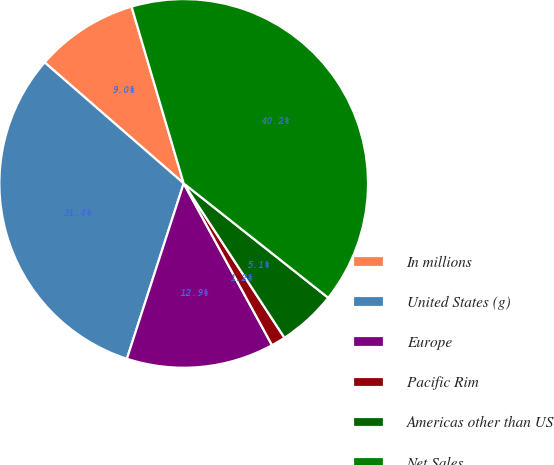Convert chart. <chart><loc_0><loc_0><loc_500><loc_500><pie_chart><fcel>In millions<fcel>United States (g)<fcel>Europe<fcel>Pacific Rim<fcel>Americas other than US<fcel>Net Sales<nl><fcel>9.04%<fcel>31.41%<fcel>12.94%<fcel>1.25%<fcel>5.14%<fcel>40.22%<nl></chart> 